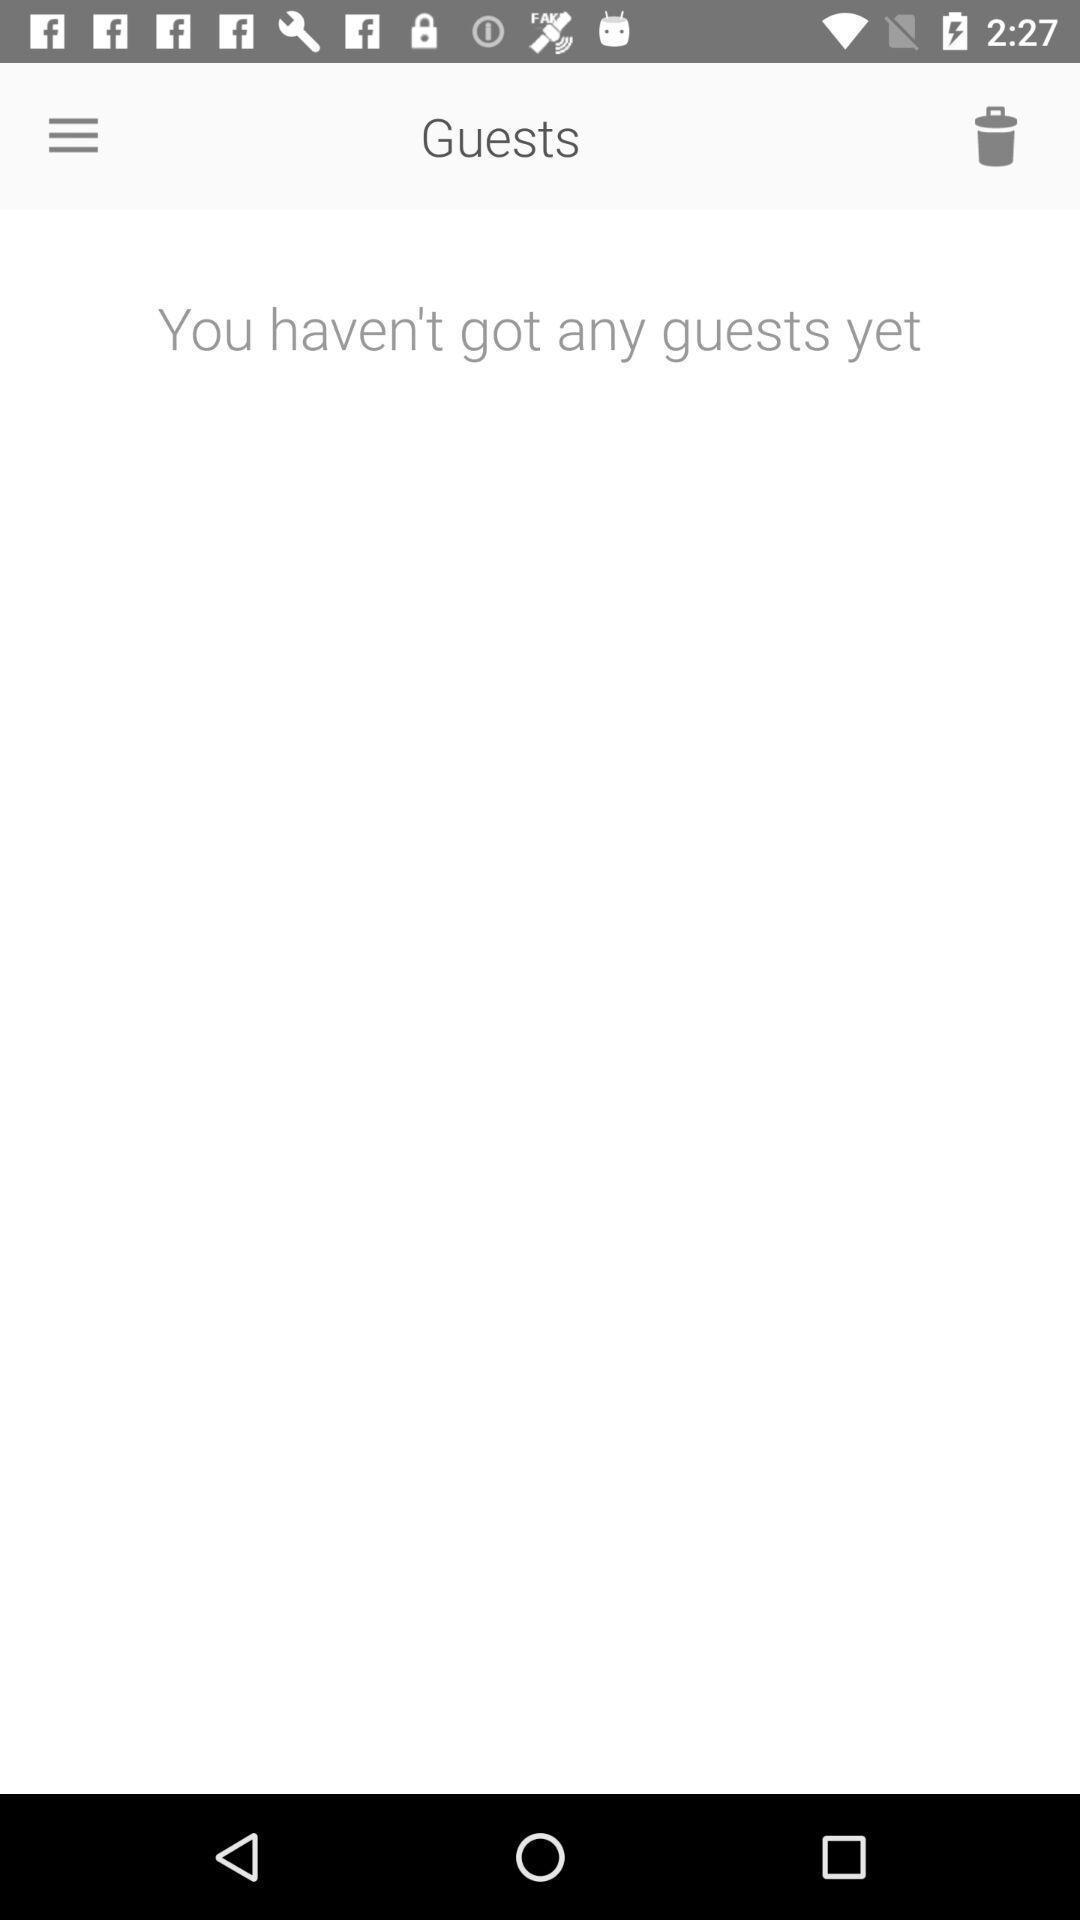Summarize the information in this screenshot. Welcome page of a dating app. 